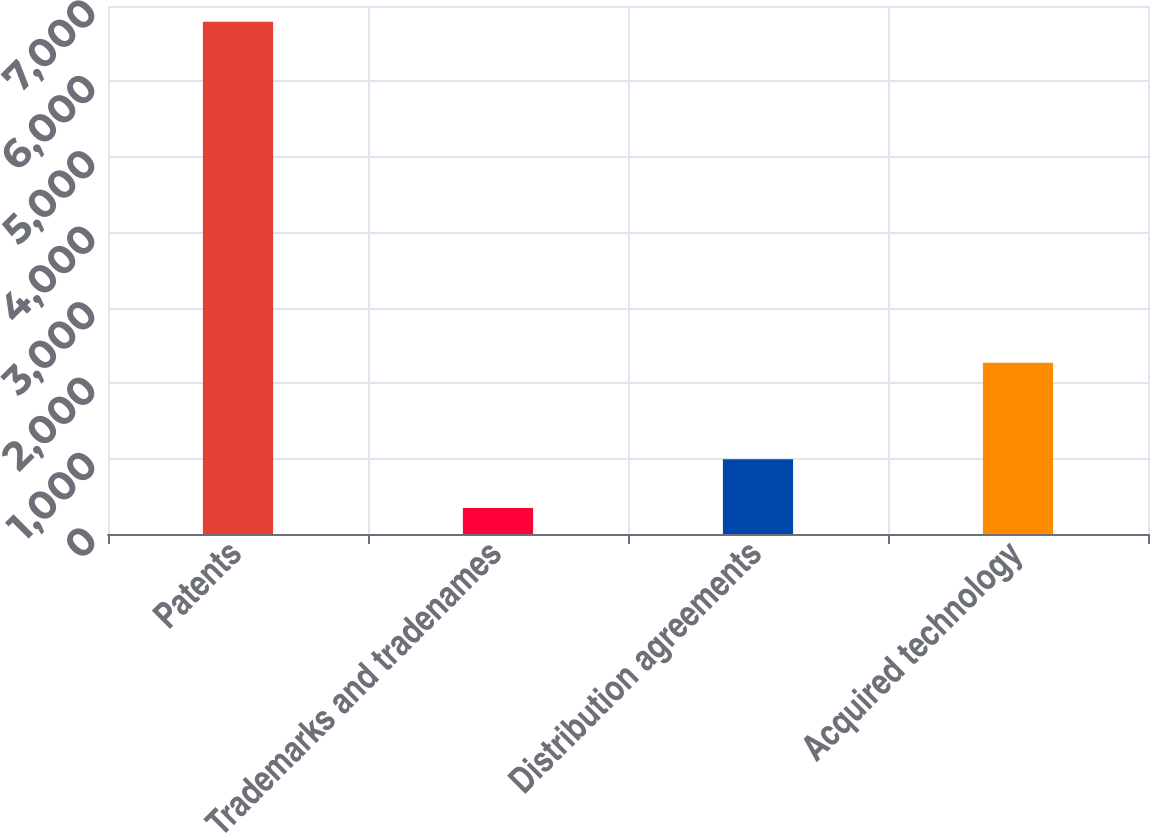<chart> <loc_0><loc_0><loc_500><loc_500><bar_chart><fcel>Patents<fcel>Trademarks and tradenames<fcel>Distribution agreements<fcel>Acquired technology<nl><fcel>6790<fcel>345<fcel>989.5<fcel>2272<nl></chart> 